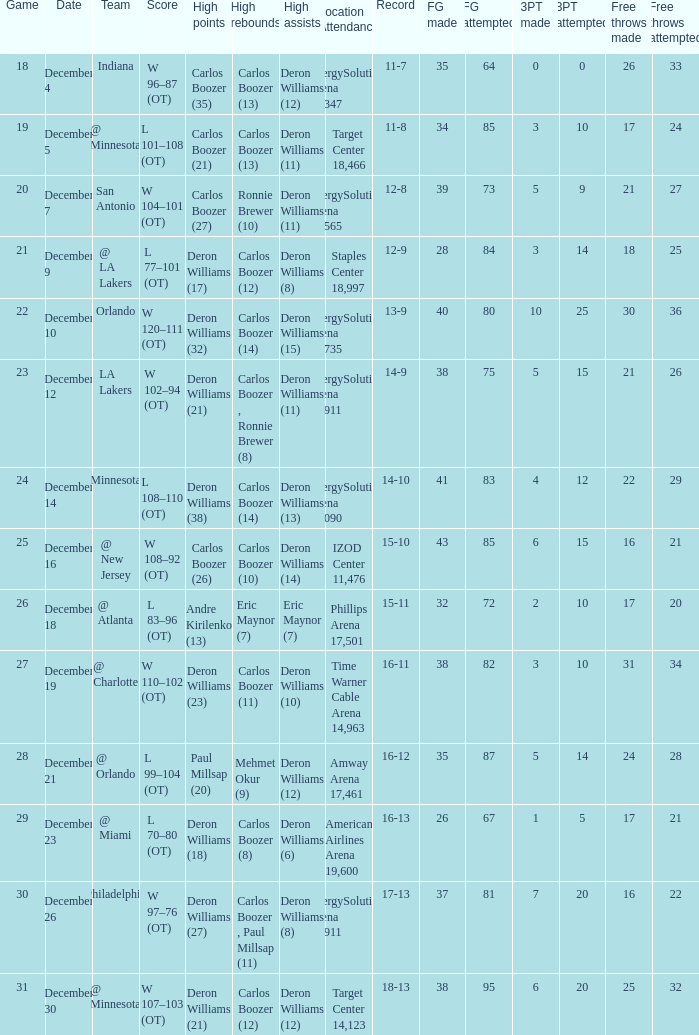When was the game in which Deron Williams (13) did the high assists played? December 14. Can you parse all the data within this table? {'header': ['Game', 'Date', 'Team', 'Score', 'High points', 'High rebounds', 'High assists', 'Location Attendance', 'Record', 'FG made', 'FG attempted', '3PT made', '3PT attempted', 'Free throws made', 'Free throws attempted '], 'rows': [['18', 'December 4', 'Indiana', 'W 96–87 (OT)', 'Carlos Boozer (35)', 'Carlos Boozer (13)', 'Deron Williams (12)', 'EnergySolutions Arena 19,347', '11-7', '35', '64', '0', '0', '26', '33'], ['19', 'December 5', '@ Minnesota', 'L 101–108 (OT)', 'Carlos Boozer (21)', 'Carlos Boozer (13)', 'Deron Williams (11)', 'Target Center 18,466', '11-8', '34', '85', '3', '10', '17', '24'], ['20', 'December 7', 'San Antonio', 'W 104–101 (OT)', 'Carlos Boozer (27)', 'Ronnie Brewer (10)', 'Deron Williams (11)', 'EnergySolutions Arena 17,565', '12-8', '39', '73', '5', '9', '21', '27'], ['21', 'December 9', '@ LA Lakers', 'L 77–101 (OT)', 'Deron Williams (17)', 'Carlos Boozer (12)', 'Deron Williams (8)', 'Staples Center 18,997', '12-9', '28', '84', '3', '14', '18', '25'], ['22', 'December 10', 'Orlando', 'W 120–111 (OT)', 'Deron Williams (32)', 'Carlos Boozer (14)', 'Deron Williams (15)', 'EnergySolutions Arena 18,735', '13-9', '40', '80', '10', '25', '30', '36'], ['23', 'December 12', 'LA Lakers', 'W 102–94 (OT)', 'Deron Williams (21)', 'Carlos Boozer , Ronnie Brewer (8)', 'Deron Williams (11)', 'EnergySolutions Arena 19,911', '14-9', '38', '75', '5', '15', '21', '26'], ['24', 'December 14', 'Minnesota', 'L 108–110 (OT)', 'Deron Williams (38)', 'Carlos Boozer (14)', 'Deron Williams (13)', 'EnergySolutions Arena 18,090', '14-10', '41', '83', '4', '12', '22', '29'], ['25', 'December 16', '@ New Jersey', 'W 108–92 (OT)', 'Carlos Boozer (26)', 'Carlos Boozer (10)', 'Deron Williams (14)', 'IZOD Center 11,476', '15-10', '43', '85', '6', '15', '16', '21'], ['26', 'December 18', '@ Atlanta', 'L 83–96 (OT)', 'Andre Kirilenko (13)', 'Eric Maynor (7)', 'Eric Maynor (7)', 'Phillips Arena 17,501', '15-11', '32', '72', '2', '10', '17', '20'], ['27', 'December 19', '@ Charlotte', 'W 110–102 (OT)', 'Deron Williams (23)', 'Carlos Boozer (11)', 'Deron Williams (10)', 'Time Warner Cable Arena 14,963', '16-11', '38', '82', '3', '10', '31', '34'], ['28', 'December 21', '@ Orlando', 'L 99–104 (OT)', 'Paul Millsap (20)', 'Mehmet Okur (9)', 'Deron Williams (12)', 'Amway Arena 17,461', '16-12', '35', '87', '5', '14', '24', '28'], ['29', 'December 23', '@ Miami', 'L 70–80 (OT)', 'Deron Williams (18)', 'Carlos Boozer (8)', 'Deron Williams (6)', 'American Airlines Arena 19,600', '16-13', '26', '67', '1', '5', '17', '21'], ['30', 'December 26', 'Philadelphia', 'W 97–76 (OT)', 'Deron Williams (27)', 'Carlos Boozer , Paul Millsap (11)', 'Deron Williams (8)', 'EnergySolutions Arena 19,911', '17-13', '37', '81', '7', '20', '16', '22'], ['31', 'December 30', '@ Minnesota', 'W 107–103 (OT)', 'Deron Williams (21)', 'Carlos Boozer (12)', 'Deron Williams (12)', 'Target Center 14,123', '18-13', '38', '95', '6', '20', '25', '32']]} 